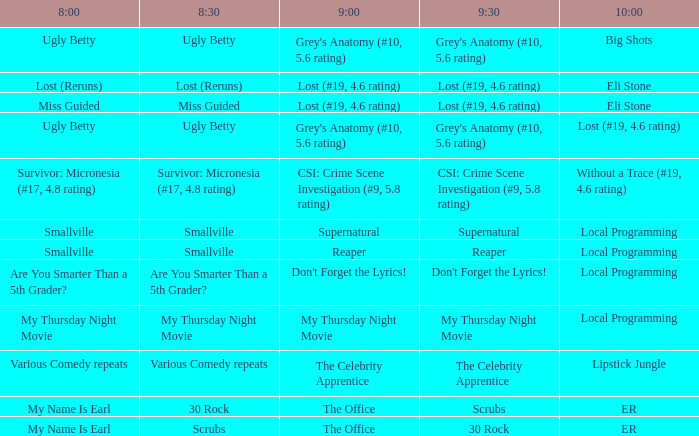Parse the table in full. {'header': ['8:00', '8:30', '9:00', '9:30', '10:00'], 'rows': [['Ugly Betty', 'Ugly Betty', "Grey's Anatomy (#10, 5.6 rating)", "Grey's Anatomy (#10, 5.6 rating)", 'Big Shots'], ['Lost (Reruns)', 'Lost (Reruns)', 'Lost (#19, 4.6 rating)', 'Lost (#19, 4.6 rating)', 'Eli Stone'], ['Miss Guided', 'Miss Guided', 'Lost (#19, 4.6 rating)', 'Lost (#19, 4.6 rating)', 'Eli Stone'], ['Ugly Betty', 'Ugly Betty', "Grey's Anatomy (#10, 5.6 rating)", "Grey's Anatomy (#10, 5.6 rating)", 'Lost (#19, 4.6 rating)'], ['Survivor: Micronesia (#17, 4.8 rating)', 'Survivor: Micronesia (#17, 4.8 rating)', 'CSI: Crime Scene Investigation (#9, 5.8 rating)', 'CSI: Crime Scene Investigation (#9, 5.8 rating)', 'Without a Trace (#19, 4.6 rating)'], ['Smallville', 'Smallville', 'Supernatural', 'Supernatural', 'Local Programming'], ['Smallville', 'Smallville', 'Reaper', 'Reaper', 'Local Programming'], ['Are You Smarter Than a 5th Grader?', 'Are You Smarter Than a 5th Grader?', "Don't Forget the Lyrics!", "Don't Forget the Lyrics!", 'Local Programming'], ['My Thursday Night Movie', 'My Thursday Night Movie', 'My Thursday Night Movie', 'My Thursday Night Movie', 'Local Programming'], ['Various Comedy repeats', 'Various Comedy repeats', 'The Celebrity Apprentice', 'The Celebrity Apprentice', 'Lipstick Jungle'], ['My Name Is Earl', '30 Rock', 'The Office', 'Scrubs', 'ER'], ['My Name Is Earl', 'Scrubs', 'The Office', '30 Rock', 'ER']]} What is at 9:00 when at 10:00 it is local programming and at 9:30 it is my thursday night movie? My Thursday Night Movie. 